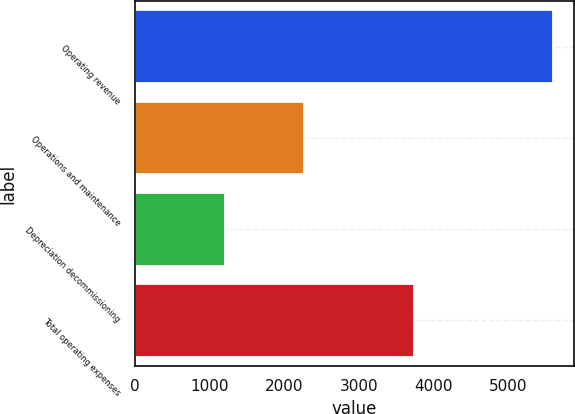<chart> <loc_0><loc_0><loc_500><loc_500><bar_chart><fcel>Operating revenue<fcel>Operations and maintenance<fcel>Depreciation decommissioning<fcel>Total operating expenses<nl><fcel>5606<fcel>2271<fcel>1213<fcel>3744<nl></chart> 